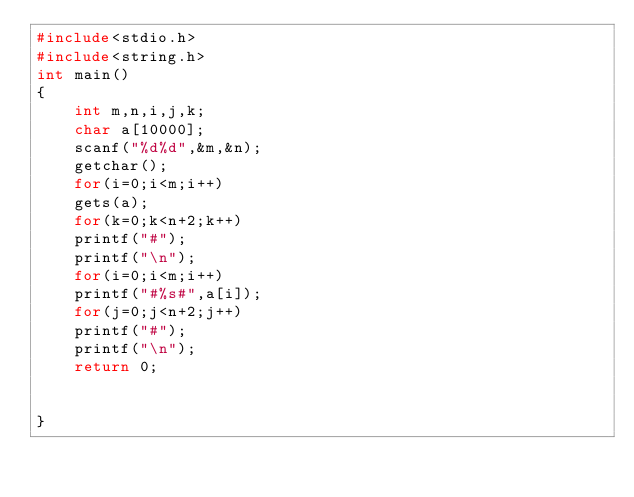<code> <loc_0><loc_0><loc_500><loc_500><_C_>#include<stdio.h>
#include<string.h>
int main()
{
	int m,n,i,j,k;
	char a[10000];
	scanf("%d%d",&m,&n);
	getchar();
	for(i=0;i<m;i++)
    gets(a);
	for(k=0;k<n+2;k++)
	printf("#");
	printf("\n");
	for(i=0;i<m;i++)
	printf("#%s#",a[i]);
	for(j=0;j<n+2;j++)
	printf("#");
	printf("\n");
	return 0;
	
	
}</code> 